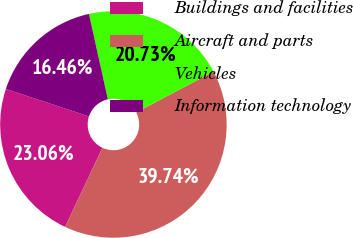Convert chart to OTSL. <chart><loc_0><loc_0><loc_500><loc_500><pie_chart><fcel>Buildings and facilities<fcel>Aircraft and parts<fcel>Vehicles<fcel>Information technology<nl><fcel>23.06%<fcel>39.74%<fcel>20.73%<fcel>16.46%<nl></chart> 